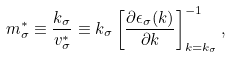Convert formula to latex. <formula><loc_0><loc_0><loc_500><loc_500>m _ { \sigma } ^ { * } \equiv \frac { k _ { \sigma } } { v _ { \sigma } ^ { * } } \equiv k _ { \sigma } \left [ \frac { \partial \epsilon _ { \sigma } ( k ) } { \partial k } \right ] _ { k = k _ { \sigma } } ^ { - 1 } ,</formula> 